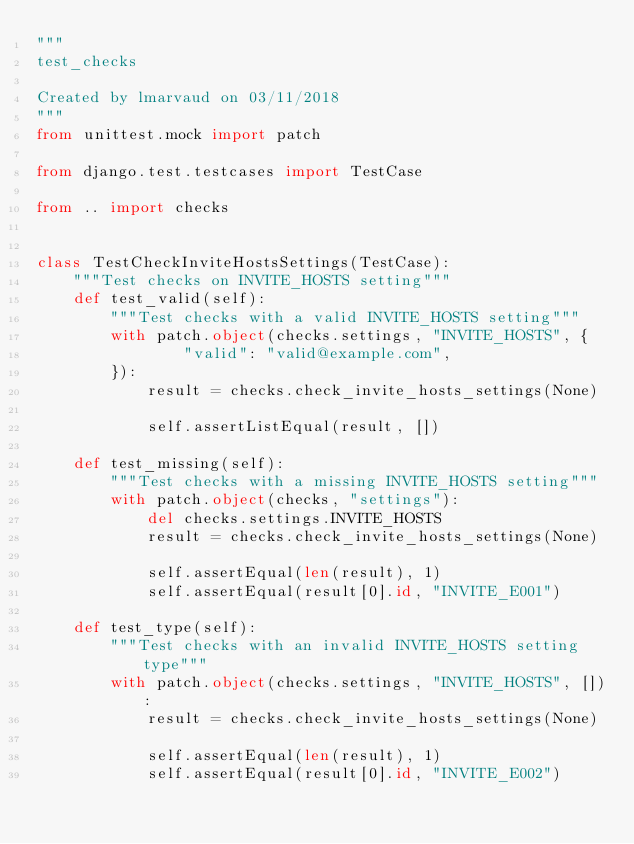Convert code to text. <code><loc_0><loc_0><loc_500><loc_500><_Python_>"""
test_checks

Created by lmarvaud on 03/11/2018
"""
from unittest.mock import patch

from django.test.testcases import TestCase

from .. import checks


class TestCheckInviteHostsSettings(TestCase):
    """Test checks on INVITE_HOSTS setting"""
    def test_valid(self):
        """Test checks with a valid INVITE_HOSTS setting"""
        with patch.object(checks.settings, "INVITE_HOSTS", {
                "valid": "valid@example.com",
        }):
            result = checks.check_invite_hosts_settings(None)

            self.assertListEqual(result, [])

    def test_missing(self):
        """Test checks with a missing INVITE_HOSTS setting"""
        with patch.object(checks, "settings"):
            del checks.settings.INVITE_HOSTS
            result = checks.check_invite_hosts_settings(None)

            self.assertEqual(len(result), 1)
            self.assertEqual(result[0].id, "INVITE_E001")

    def test_type(self):
        """Test checks with an invalid INVITE_HOSTS setting type"""
        with patch.object(checks.settings, "INVITE_HOSTS", []):
            result = checks.check_invite_hosts_settings(None)

            self.assertEqual(len(result), 1)
            self.assertEqual(result[0].id, "INVITE_E002")
</code> 